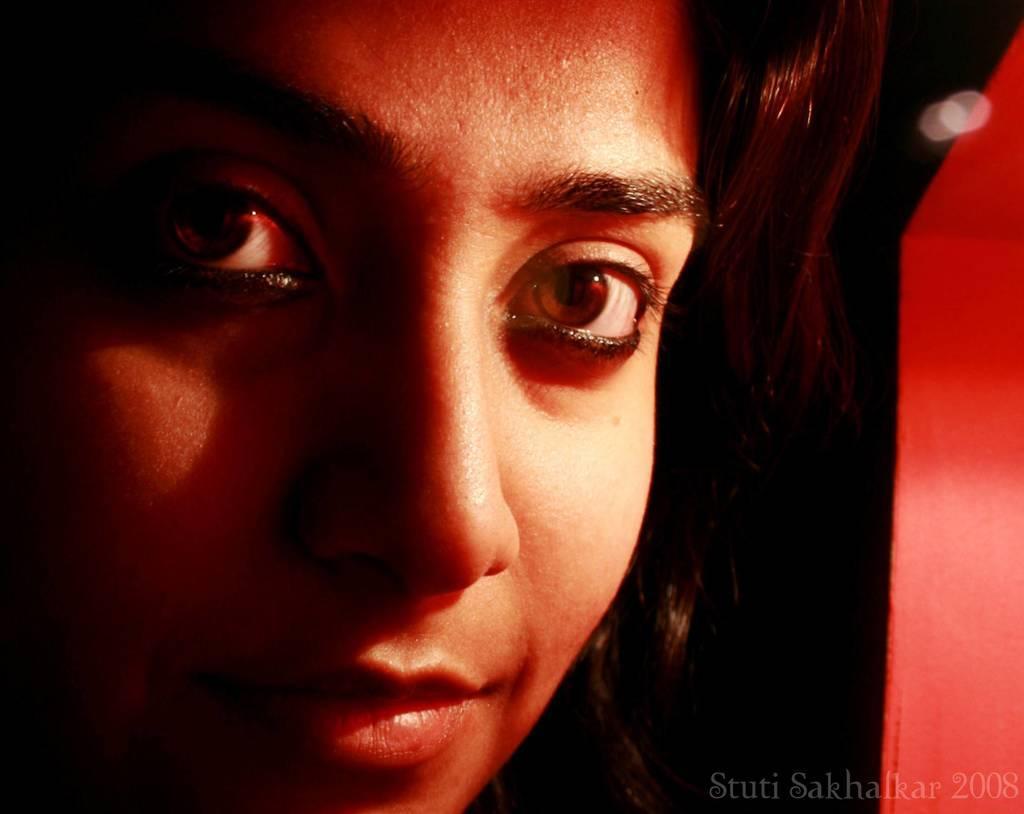In one or two sentences, can you explain what this image depicts? In this image we can see face of a lady. In the right bottom corner there is text. 